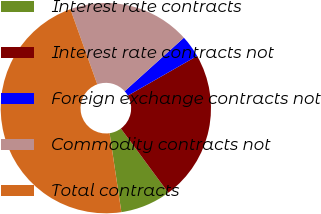Convert chart to OTSL. <chart><loc_0><loc_0><loc_500><loc_500><pie_chart><fcel>Interest rate contracts<fcel>Interest rate contracts not<fcel>Foreign exchange contracts not<fcel>Commodity contracts not<fcel>Total contracts<nl><fcel>7.77%<fcel>23.14%<fcel>3.42%<fcel>18.79%<fcel>46.89%<nl></chart> 